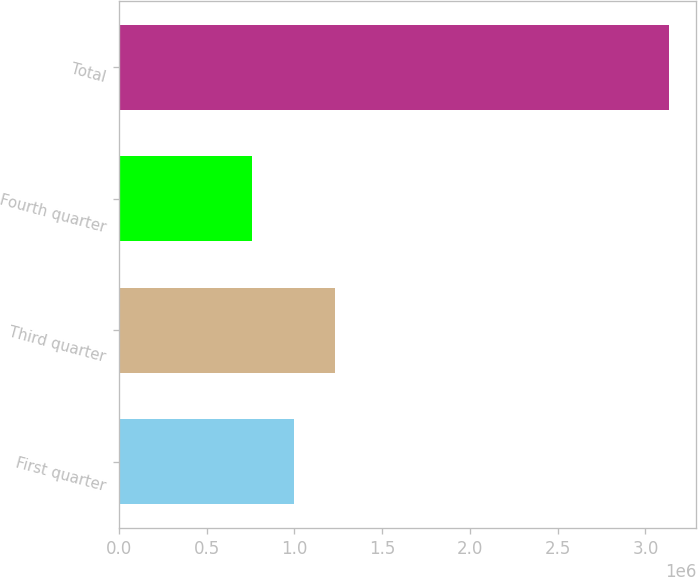Convert chart. <chart><loc_0><loc_0><loc_500><loc_500><bar_chart><fcel>First quarter<fcel>Third quarter<fcel>Fourth quarter<fcel>Total<nl><fcel>994869<fcel>1.2325e+06<fcel>757235<fcel>3.13358e+06<nl></chart> 